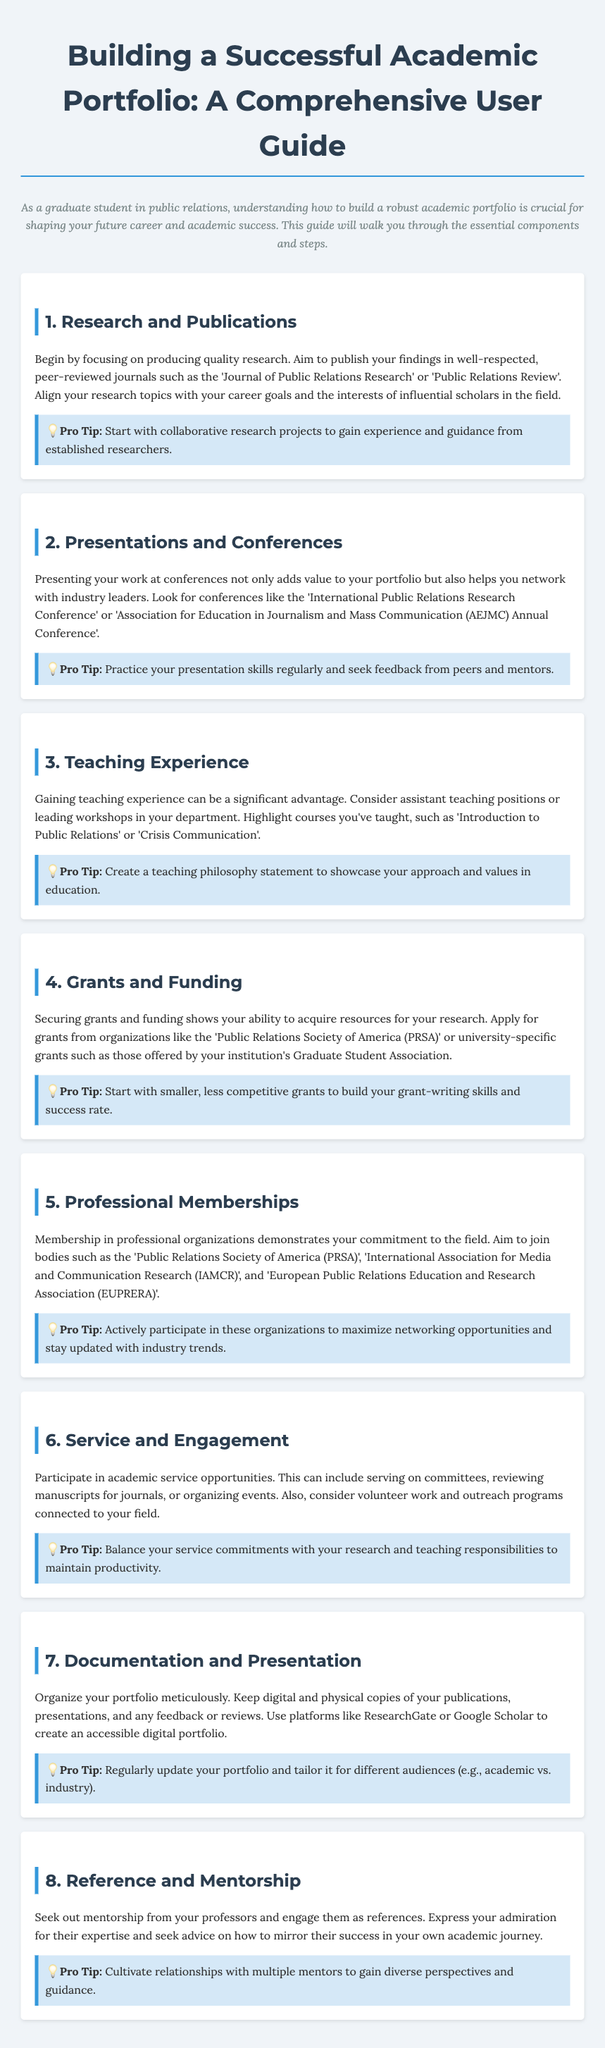what is the title of the document? The title of the document is specified in the <title> tag in the HTML, which is "Building a Successful Academic Portfolio: A Comprehensive User Guide".
Answer: Building a Successful Academic Portfolio: A Comprehensive User Guide what is a key organization to apply for grants? The document states that you can apply for grants from organizations like the 'Public Relations Society of America (PRSA)'.
Answer: Public Relations Society of America (PRSA) how many sections are there in this guide? The guide contains eight distinct sections as outlined by the headings in the document.
Answer: 8 what should be included in a teaching philosophy statement? The guide indicates that a teaching philosophy statement should showcase your approach and values in education, as stated in the teaching experience section.
Answer: Approach and values in education which research journals are mentioned for publications? The document lists 'Journal of Public Relations Research' and 'Public Relations Review' as examples of reputable journals.
Answer: Journal of Public Relations Research, Public Relations Review what should you do to enhance your teaching experience? According to the guide, you should consider assistant teaching positions or leading workshops in your department.
Answer: Assistant teaching positions or leading workshops what is a pro tip for conference presentations? The document advises that you should practice your presentation skills regularly and seek feedback from peers and mentors.
Answer: Practice presentation skills regularly and seek feedback which professional organizations should you aim to join? The guide lists several professional organizations, including the 'Public Relations Society of America (PRSA)', 'IAMCR', and 'EUPRERA'.
Answer: Public Relations Society of America (PRSA), IAMCR, EUPRERA 